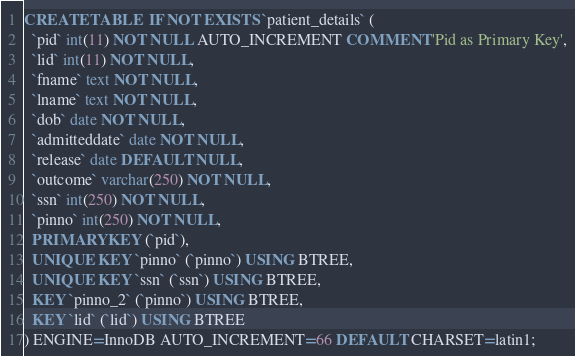Convert code to text. <code><loc_0><loc_0><loc_500><loc_500><_SQL_>CREATE TABLE  IF NOT EXISTS `patient_details` (
  `pid` int(11) NOT NULL AUTO_INCREMENT COMMENT 'Pid as Primary Key',
  `lid` int(11) NOT NULL,
  `fname` text NOT NULL,
  `lname` text NOT NULL,
  `dob` date NOT NULL,
  `admitteddate` date NOT NULL,
  `release` date DEFAULT NULL,
  `outcome` varchar(250) NOT NULL,
  `ssn` int(250) NOT NULL,
  `pinno` int(250) NOT NULL,
  PRIMARY KEY (`pid`),
  UNIQUE KEY `pinno` (`pinno`) USING BTREE,
  UNIQUE KEY `ssn` (`ssn`) USING BTREE,
  KEY `pinno_2` (`pinno`) USING BTREE,
  KEY `lid` (`lid`) USING BTREE
) ENGINE=InnoDB AUTO_INCREMENT=66 DEFAULT CHARSET=latin1;
</code> 